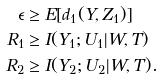Convert formula to latex. <formula><loc_0><loc_0><loc_500><loc_500>\epsilon & \geq E [ d _ { 1 } ( Y , Z _ { 1 } ) ] \\ R _ { 1 } & \geq I ( Y _ { 1 } ; U _ { 1 } | W , T ) \\ R _ { 2 } & \geq I ( Y _ { 2 } ; U _ { 2 } | W , T ) .</formula> 